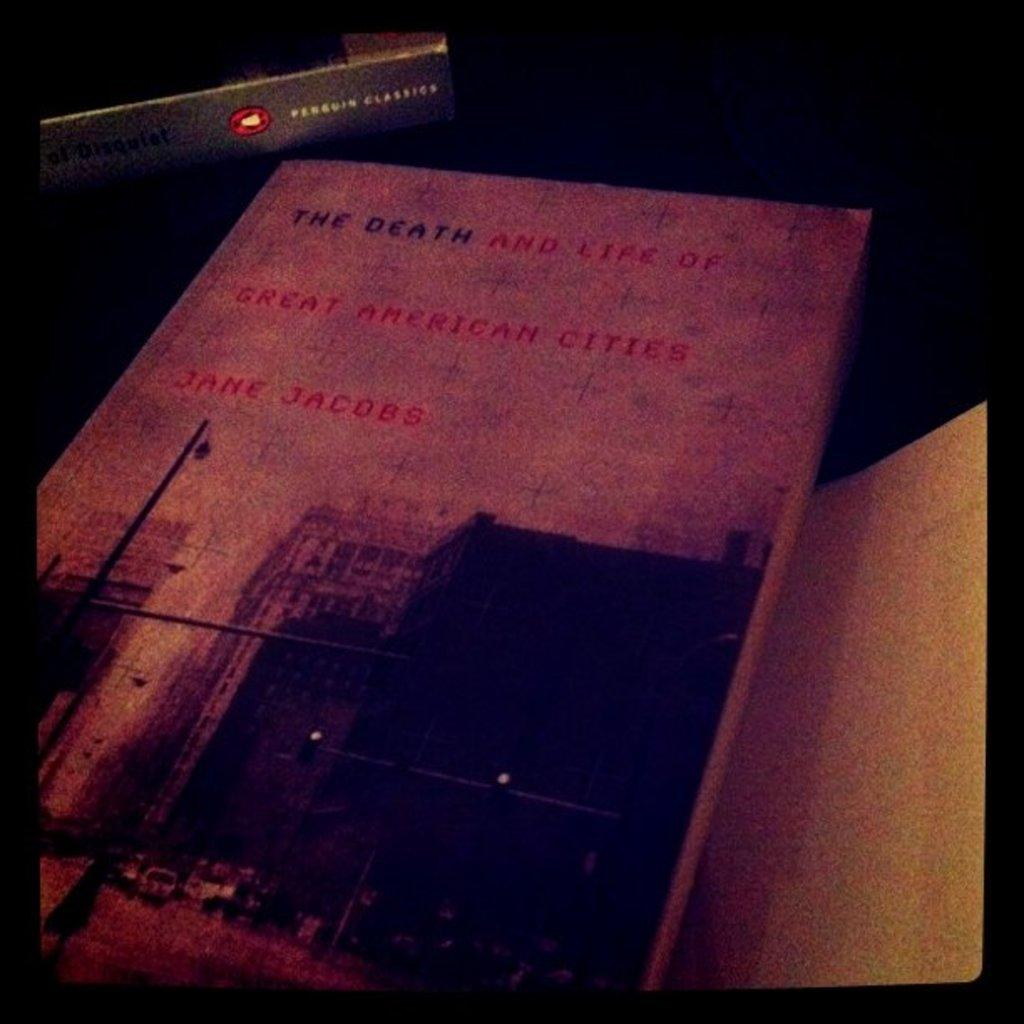<image>
Describe the image concisely. A book on a desk titled, the death and life of Jane Jacobs. 